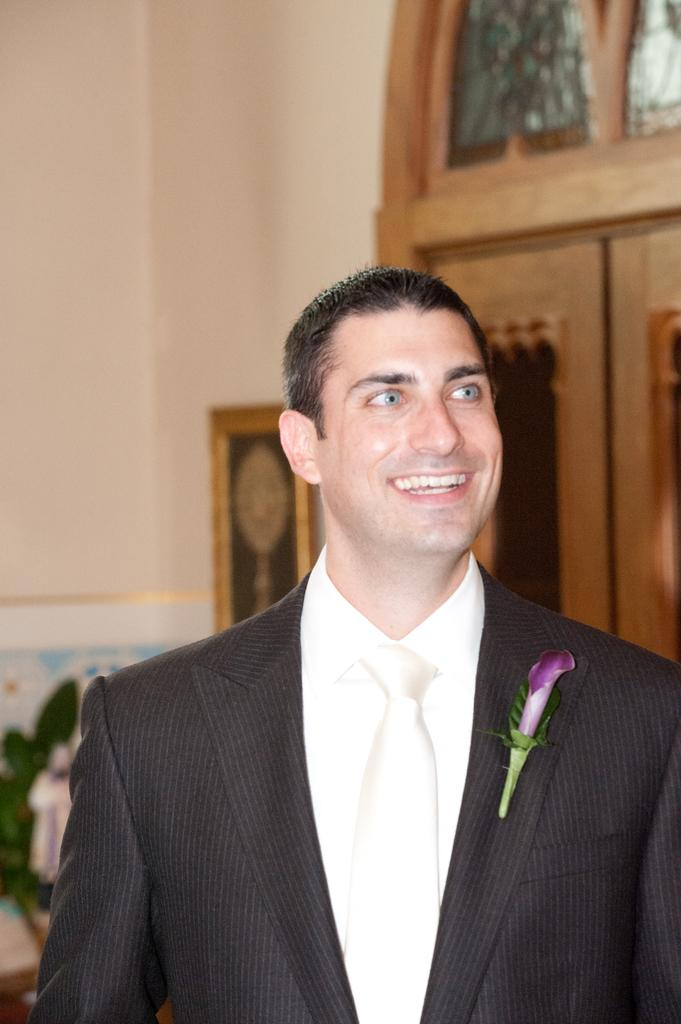What is the person in the image wearing? The person in the image is wearing a suit. What can be seen behind the person in the image? There is a wall in the image. What decorative items are present in the image? There are photo frames in the image. Is there any entrance or exit visible in the image? Yes, there is a door in the image. How does the person in the image tie a knot with the zinc? There is no zinc or knot-tying activity present in the image; the person is simply wearing a suit. 